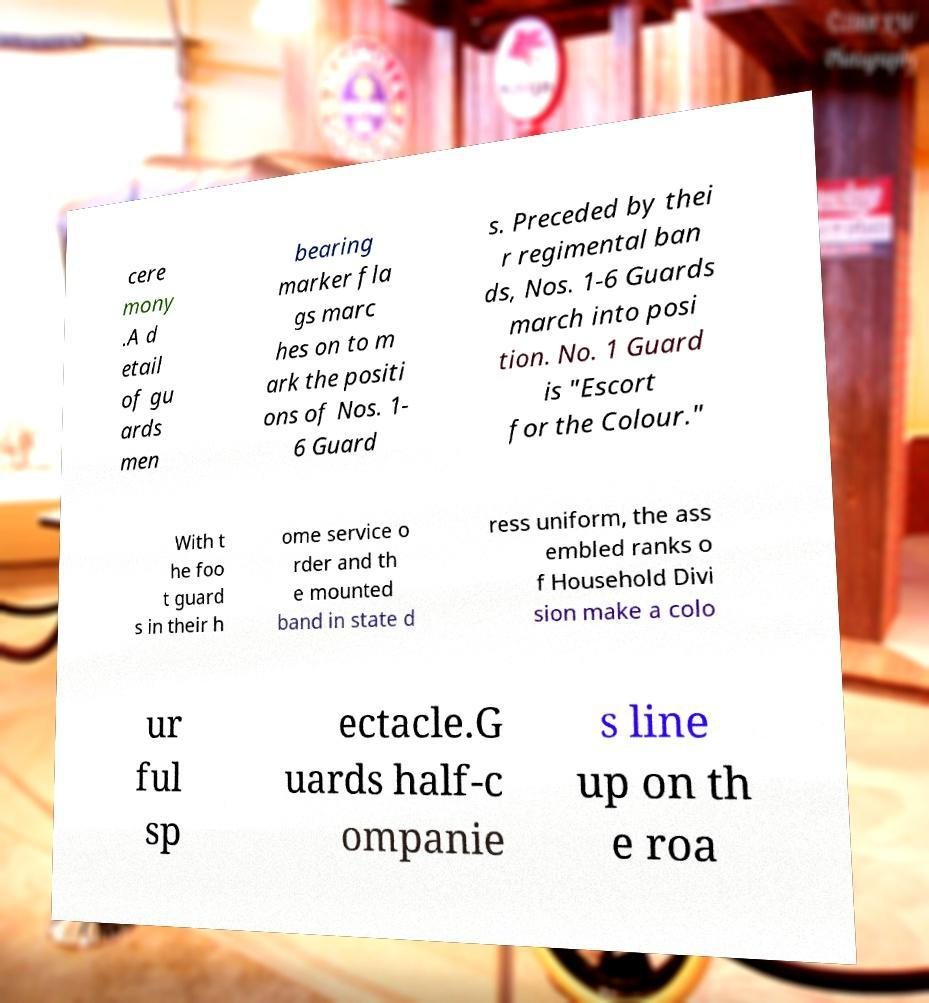Please read and relay the text visible in this image. What does it say? cere mony .A d etail of gu ards men bearing marker fla gs marc hes on to m ark the positi ons of Nos. 1- 6 Guard s. Preceded by thei r regimental ban ds, Nos. 1-6 Guards march into posi tion. No. 1 Guard is "Escort for the Colour." With t he foo t guard s in their h ome service o rder and th e mounted band in state d ress uniform, the ass embled ranks o f Household Divi sion make a colo ur ful sp ectacle.G uards half-c ompanie s line up on th e roa 